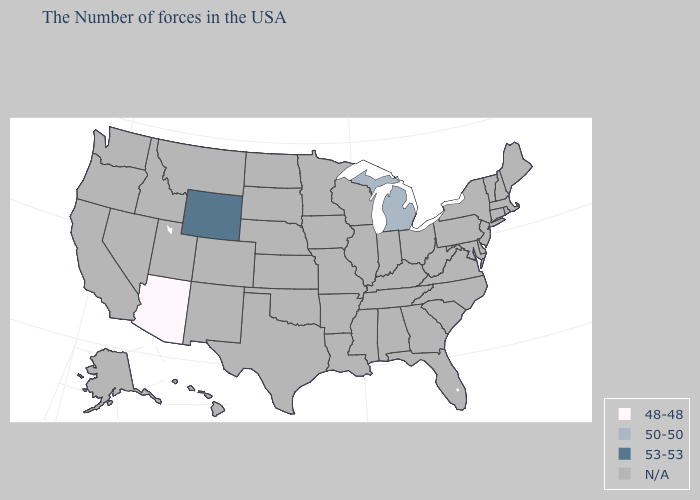Name the states that have a value in the range 50-50?
Quick response, please. Michigan. Name the states that have a value in the range N/A?
Write a very short answer. Maine, Massachusetts, Rhode Island, New Hampshire, Vermont, Connecticut, New York, New Jersey, Delaware, Maryland, Pennsylvania, Virginia, North Carolina, South Carolina, West Virginia, Ohio, Florida, Georgia, Kentucky, Indiana, Alabama, Tennessee, Wisconsin, Illinois, Mississippi, Louisiana, Missouri, Arkansas, Minnesota, Iowa, Kansas, Nebraska, Oklahoma, Texas, South Dakota, North Dakota, Colorado, New Mexico, Utah, Montana, Idaho, Nevada, California, Washington, Oregon, Alaska, Hawaii. Name the states that have a value in the range 48-48?
Quick response, please. Arizona. Which states have the highest value in the USA?
Quick response, please. Wyoming. What is the value of New York?
Quick response, please. N/A. What is the value of Pennsylvania?
Short answer required. N/A. Does the first symbol in the legend represent the smallest category?
Short answer required. Yes. Does the map have missing data?
Write a very short answer. Yes. Which states have the lowest value in the USA?
Give a very brief answer. Arizona. 